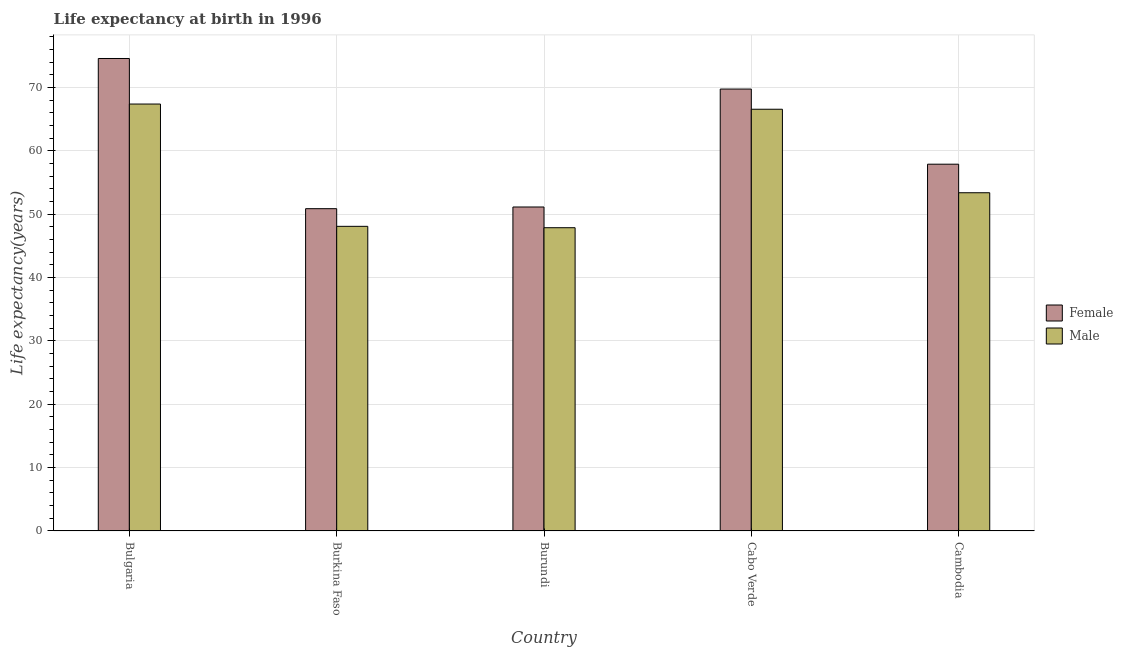How many different coloured bars are there?
Your answer should be compact. 2. Are the number of bars per tick equal to the number of legend labels?
Provide a succinct answer. Yes. What is the label of the 5th group of bars from the left?
Give a very brief answer. Cambodia. In how many cases, is the number of bars for a given country not equal to the number of legend labels?
Provide a short and direct response. 0. What is the life expectancy(male) in Burundi?
Offer a terse response. 47.87. Across all countries, what is the maximum life expectancy(female)?
Give a very brief answer. 74.58. Across all countries, what is the minimum life expectancy(female)?
Your answer should be very brief. 50.87. In which country was the life expectancy(male) maximum?
Give a very brief answer. Bulgaria. In which country was the life expectancy(female) minimum?
Offer a terse response. Burkina Faso. What is the total life expectancy(female) in the graph?
Ensure brevity in your answer.  304.24. What is the difference between the life expectancy(male) in Cabo Verde and that in Cambodia?
Provide a succinct answer. 13.18. What is the difference between the life expectancy(female) in Burundi and the life expectancy(male) in Cabo Verde?
Your answer should be very brief. -15.43. What is the average life expectancy(female) per country?
Offer a terse response. 60.85. What is the difference between the life expectancy(female) and life expectancy(male) in Burundi?
Your response must be concise. 3.27. What is the ratio of the life expectancy(male) in Bulgaria to that in Burundi?
Keep it short and to the point. 1.41. What is the difference between the highest and the second highest life expectancy(female)?
Keep it short and to the point. 4.83. What is the difference between the highest and the lowest life expectancy(male)?
Keep it short and to the point. 19.52. In how many countries, is the life expectancy(female) greater than the average life expectancy(female) taken over all countries?
Your response must be concise. 2. What does the 2nd bar from the left in Burundi represents?
Give a very brief answer. Male. How many bars are there?
Ensure brevity in your answer.  10. How many countries are there in the graph?
Your answer should be compact. 5. What is the difference between two consecutive major ticks on the Y-axis?
Provide a succinct answer. 10. Are the values on the major ticks of Y-axis written in scientific E-notation?
Your answer should be very brief. No. Does the graph contain grids?
Your answer should be very brief. Yes. Where does the legend appear in the graph?
Offer a terse response. Center right. How are the legend labels stacked?
Your answer should be very brief. Vertical. What is the title of the graph?
Offer a terse response. Life expectancy at birth in 1996. Does "Methane emissions" appear as one of the legend labels in the graph?
Your answer should be compact. No. What is the label or title of the X-axis?
Keep it short and to the point. Country. What is the label or title of the Y-axis?
Your response must be concise. Life expectancy(years). What is the Life expectancy(years) in Female in Bulgaria?
Offer a very short reply. 74.58. What is the Life expectancy(years) in Male in Bulgaria?
Make the answer very short. 67.39. What is the Life expectancy(years) of Female in Burkina Faso?
Keep it short and to the point. 50.87. What is the Life expectancy(years) in Male in Burkina Faso?
Provide a succinct answer. 48.08. What is the Life expectancy(years) in Female in Burundi?
Keep it short and to the point. 51.14. What is the Life expectancy(years) of Male in Burundi?
Give a very brief answer. 47.87. What is the Life expectancy(years) in Female in Cabo Verde?
Provide a short and direct response. 69.75. What is the Life expectancy(years) in Male in Cabo Verde?
Give a very brief answer. 66.57. What is the Life expectancy(years) in Female in Cambodia?
Provide a succinct answer. 57.9. What is the Life expectancy(years) of Male in Cambodia?
Give a very brief answer. 53.39. Across all countries, what is the maximum Life expectancy(years) of Female?
Your answer should be very brief. 74.58. Across all countries, what is the maximum Life expectancy(years) in Male?
Your answer should be compact. 67.39. Across all countries, what is the minimum Life expectancy(years) in Female?
Provide a succinct answer. 50.87. Across all countries, what is the minimum Life expectancy(years) of Male?
Offer a terse response. 47.87. What is the total Life expectancy(years) in Female in the graph?
Provide a short and direct response. 304.24. What is the total Life expectancy(years) in Male in the graph?
Provide a succinct answer. 283.3. What is the difference between the Life expectancy(years) in Female in Bulgaria and that in Burkina Faso?
Offer a very short reply. 23.71. What is the difference between the Life expectancy(years) in Male in Bulgaria and that in Burkina Faso?
Make the answer very short. 19.31. What is the difference between the Life expectancy(years) in Female in Bulgaria and that in Burundi?
Give a very brief answer. 23.44. What is the difference between the Life expectancy(years) in Male in Bulgaria and that in Burundi?
Offer a very short reply. 19.52. What is the difference between the Life expectancy(years) in Female in Bulgaria and that in Cabo Verde?
Provide a short and direct response. 4.83. What is the difference between the Life expectancy(years) of Male in Bulgaria and that in Cabo Verde?
Make the answer very short. 0.82. What is the difference between the Life expectancy(years) of Female in Bulgaria and that in Cambodia?
Your response must be concise. 16.68. What is the difference between the Life expectancy(years) in Male in Bulgaria and that in Cambodia?
Provide a succinct answer. 14. What is the difference between the Life expectancy(years) in Female in Burkina Faso and that in Burundi?
Give a very brief answer. -0.27. What is the difference between the Life expectancy(years) of Male in Burkina Faso and that in Burundi?
Offer a very short reply. 0.22. What is the difference between the Life expectancy(years) of Female in Burkina Faso and that in Cabo Verde?
Make the answer very short. -18.88. What is the difference between the Life expectancy(years) of Male in Burkina Faso and that in Cabo Verde?
Your answer should be compact. -18.48. What is the difference between the Life expectancy(years) of Female in Burkina Faso and that in Cambodia?
Provide a succinct answer. -7.02. What is the difference between the Life expectancy(years) of Male in Burkina Faso and that in Cambodia?
Offer a very short reply. -5.3. What is the difference between the Life expectancy(years) of Female in Burundi and that in Cabo Verde?
Make the answer very short. -18.62. What is the difference between the Life expectancy(years) in Male in Burundi and that in Cabo Verde?
Keep it short and to the point. -18.7. What is the difference between the Life expectancy(years) in Female in Burundi and that in Cambodia?
Provide a succinct answer. -6.76. What is the difference between the Life expectancy(years) of Male in Burundi and that in Cambodia?
Your answer should be compact. -5.52. What is the difference between the Life expectancy(years) in Female in Cabo Verde and that in Cambodia?
Provide a succinct answer. 11.86. What is the difference between the Life expectancy(years) in Male in Cabo Verde and that in Cambodia?
Keep it short and to the point. 13.18. What is the difference between the Life expectancy(years) in Female in Bulgaria and the Life expectancy(years) in Male in Burkina Faso?
Offer a very short reply. 26.5. What is the difference between the Life expectancy(years) of Female in Bulgaria and the Life expectancy(years) of Male in Burundi?
Give a very brief answer. 26.71. What is the difference between the Life expectancy(years) in Female in Bulgaria and the Life expectancy(years) in Male in Cabo Verde?
Keep it short and to the point. 8.01. What is the difference between the Life expectancy(years) in Female in Bulgaria and the Life expectancy(years) in Male in Cambodia?
Your response must be concise. 21.19. What is the difference between the Life expectancy(years) in Female in Burkina Faso and the Life expectancy(years) in Male in Burundi?
Keep it short and to the point. 3. What is the difference between the Life expectancy(years) in Female in Burkina Faso and the Life expectancy(years) in Male in Cabo Verde?
Provide a short and direct response. -15.7. What is the difference between the Life expectancy(years) in Female in Burkina Faso and the Life expectancy(years) in Male in Cambodia?
Provide a short and direct response. -2.52. What is the difference between the Life expectancy(years) in Female in Burundi and the Life expectancy(years) in Male in Cabo Verde?
Your response must be concise. -15.43. What is the difference between the Life expectancy(years) in Female in Burundi and the Life expectancy(years) in Male in Cambodia?
Give a very brief answer. -2.25. What is the difference between the Life expectancy(years) of Female in Cabo Verde and the Life expectancy(years) of Male in Cambodia?
Provide a succinct answer. 16.37. What is the average Life expectancy(years) of Female per country?
Your answer should be very brief. 60.85. What is the average Life expectancy(years) in Male per country?
Provide a short and direct response. 56.66. What is the difference between the Life expectancy(years) of Female and Life expectancy(years) of Male in Bulgaria?
Your response must be concise. 7.19. What is the difference between the Life expectancy(years) of Female and Life expectancy(years) of Male in Burkina Faso?
Give a very brief answer. 2.79. What is the difference between the Life expectancy(years) of Female and Life expectancy(years) of Male in Burundi?
Keep it short and to the point. 3.27. What is the difference between the Life expectancy(years) in Female and Life expectancy(years) in Male in Cabo Verde?
Provide a short and direct response. 3.19. What is the difference between the Life expectancy(years) of Female and Life expectancy(years) of Male in Cambodia?
Your response must be concise. 4.51. What is the ratio of the Life expectancy(years) in Female in Bulgaria to that in Burkina Faso?
Keep it short and to the point. 1.47. What is the ratio of the Life expectancy(years) of Male in Bulgaria to that in Burkina Faso?
Provide a succinct answer. 1.4. What is the ratio of the Life expectancy(years) of Female in Bulgaria to that in Burundi?
Provide a short and direct response. 1.46. What is the ratio of the Life expectancy(years) of Male in Bulgaria to that in Burundi?
Offer a very short reply. 1.41. What is the ratio of the Life expectancy(years) of Female in Bulgaria to that in Cabo Verde?
Your answer should be compact. 1.07. What is the ratio of the Life expectancy(years) in Male in Bulgaria to that in Cabo Verde?
Offer a very short reply. 1.01. What is the ratio of the Life expectancy(years) in Female in Bulgaria to that in Cambodia?
Ensure brevity in your answer.  1.29. What is the ratio of the Life expectancy(years) in Male in Bulgaria to that in Cambodia?
Offer a very short reply. 1.26. What is the ratio of the Life expectancy(years) in Female in Burkina Faso to that in Cabo Verde?
Ensure brevity in your answer.  0.73. What is the ratio of the Life expectancy(years) of Male in Burkina Faso to that in Cabo Verde?
Provide a succinct answer. 0.72. What is the ratio of the Life expectancy(years) of Female in Burkina Faso to that in Cambodia?
Ensure brevity in your answer.  0.88. What is the ratio of the Life expectancy(years) in Male in Burkina Faso to that in Cambodia?
Your answer should be very brief. 0.9. What is the ratio of the Life expectancy(years) of Female in Burundi to that in Cabo Verde?
Give a very brief answer. 0.73. What is the ratio of the Life expectancy(years) of Male in Burundi to that in Cabo Verde?
Your answer should be very brief. 0.72. What is the ratio of the Life expectancy(years) of Female in Burundi to that in Cambodia?
Provide a succinct answer. 0.88. What is the ratio of the Life expectancy(years) of Male in Burundi to that in Cambodia?
Your response must be concise. 0.9. What is the ratio of the Life expectancy(years) in Female in Cabo Verde to that in Cambodia?
Provide a succinct answer. 1.2. What is the ratio of the Life expectancy(years) in Male in Cabo Verde to that in Cambodia?
Make the answer very short. 1.25. What is the difference between the highest and the second highest Life expectancy(years) of Female?
Offer a terse response. 4.83. What is the difference between the highest and the second highest Life expectancy(years) in Male?
Offer a terse response. 0.82. What is the difference between the highest and the lowest Life expectancy(years) in Female?
Provide a succinct answer. 23.71. What is the difference between the highest and the lowest Life expectancy(years) in Male?
Provide a succinct answer. 19.52. 